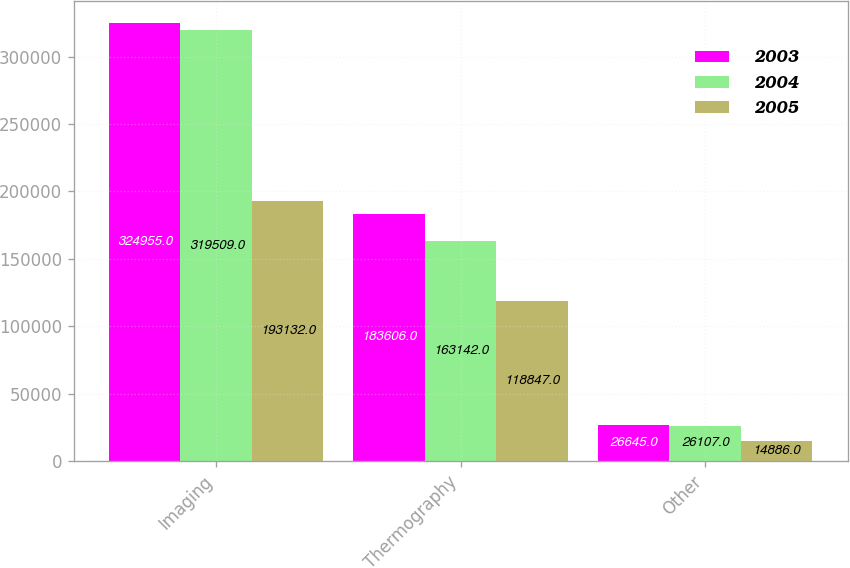<chart> <loc_0><loc_0><loc_500><loc_500><stacked_bar_chart><ecel><fcel>Imaging<fcel>Thermography<fcel>Other<nl><fcel>2003<fcel>324955<fcel>183606<fcel>26645<nl><fcel>2004<fcel>319509<fcel>163142<fcel>26107<nl><fcel>2005<fcel>193132<fcel>118847<fcel>14886<nl></chart> 